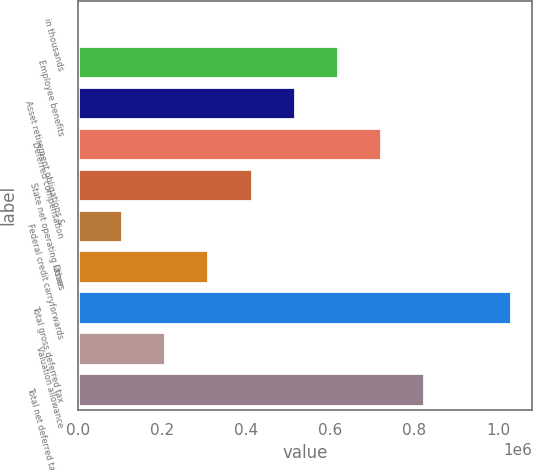Convert chart. <chart><loc_0><loc_0><loc_500><loc_500><bar_chart><fcel>in thousands<fcel>Employee benefits<fcel>Asset retirement obligations &<fcel>Deferred compensation<fcel>State net operating losses<fcel>Federal credit carryforwards<fcel>Other<fcel>Total gross deferred tax<fcel>Valuation allowance<fcel>Total net deferred tax assets<nl><fcel>2016<fcel>618077<fcel>515400<fcel>720754<fcel>412723<fcel>104693<fcel>310046<fcel>1.02878e+06<fcel>207370<fcel>823430<nl></chart> 